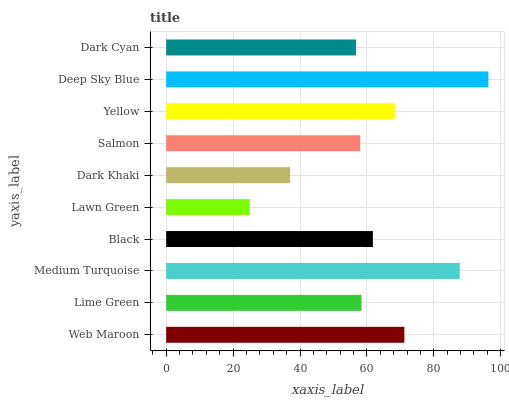Is Lawn Green the minimum?
Answer yes or no. Yes. Is Deep Sky Blue the maximum?
Answer yes or no. Yes. Is Lime Green the minimum?
Answer yes or no. No. Is Lime Green the maximum?
Answer yes or no. No. Is Web Maroon greater than Lime Green?
Answer yes or no. Yes. Is Lime Green less than Web Maroon?
Answer yes or no. Yes. Is Lime Green greater than Web Maroon?
Answer yes or no. No. Is Web Maroon less than Lime Green?
Answer yes or no. No. Is Black the high median?
Answer yes or no. Yes. Is Lime Green the low median?
Answer yes or no. Yes. Is Yellow the high median?
Answer yes or no. No. Is Dark Cyan the low median?
Answer yes or no. No. 